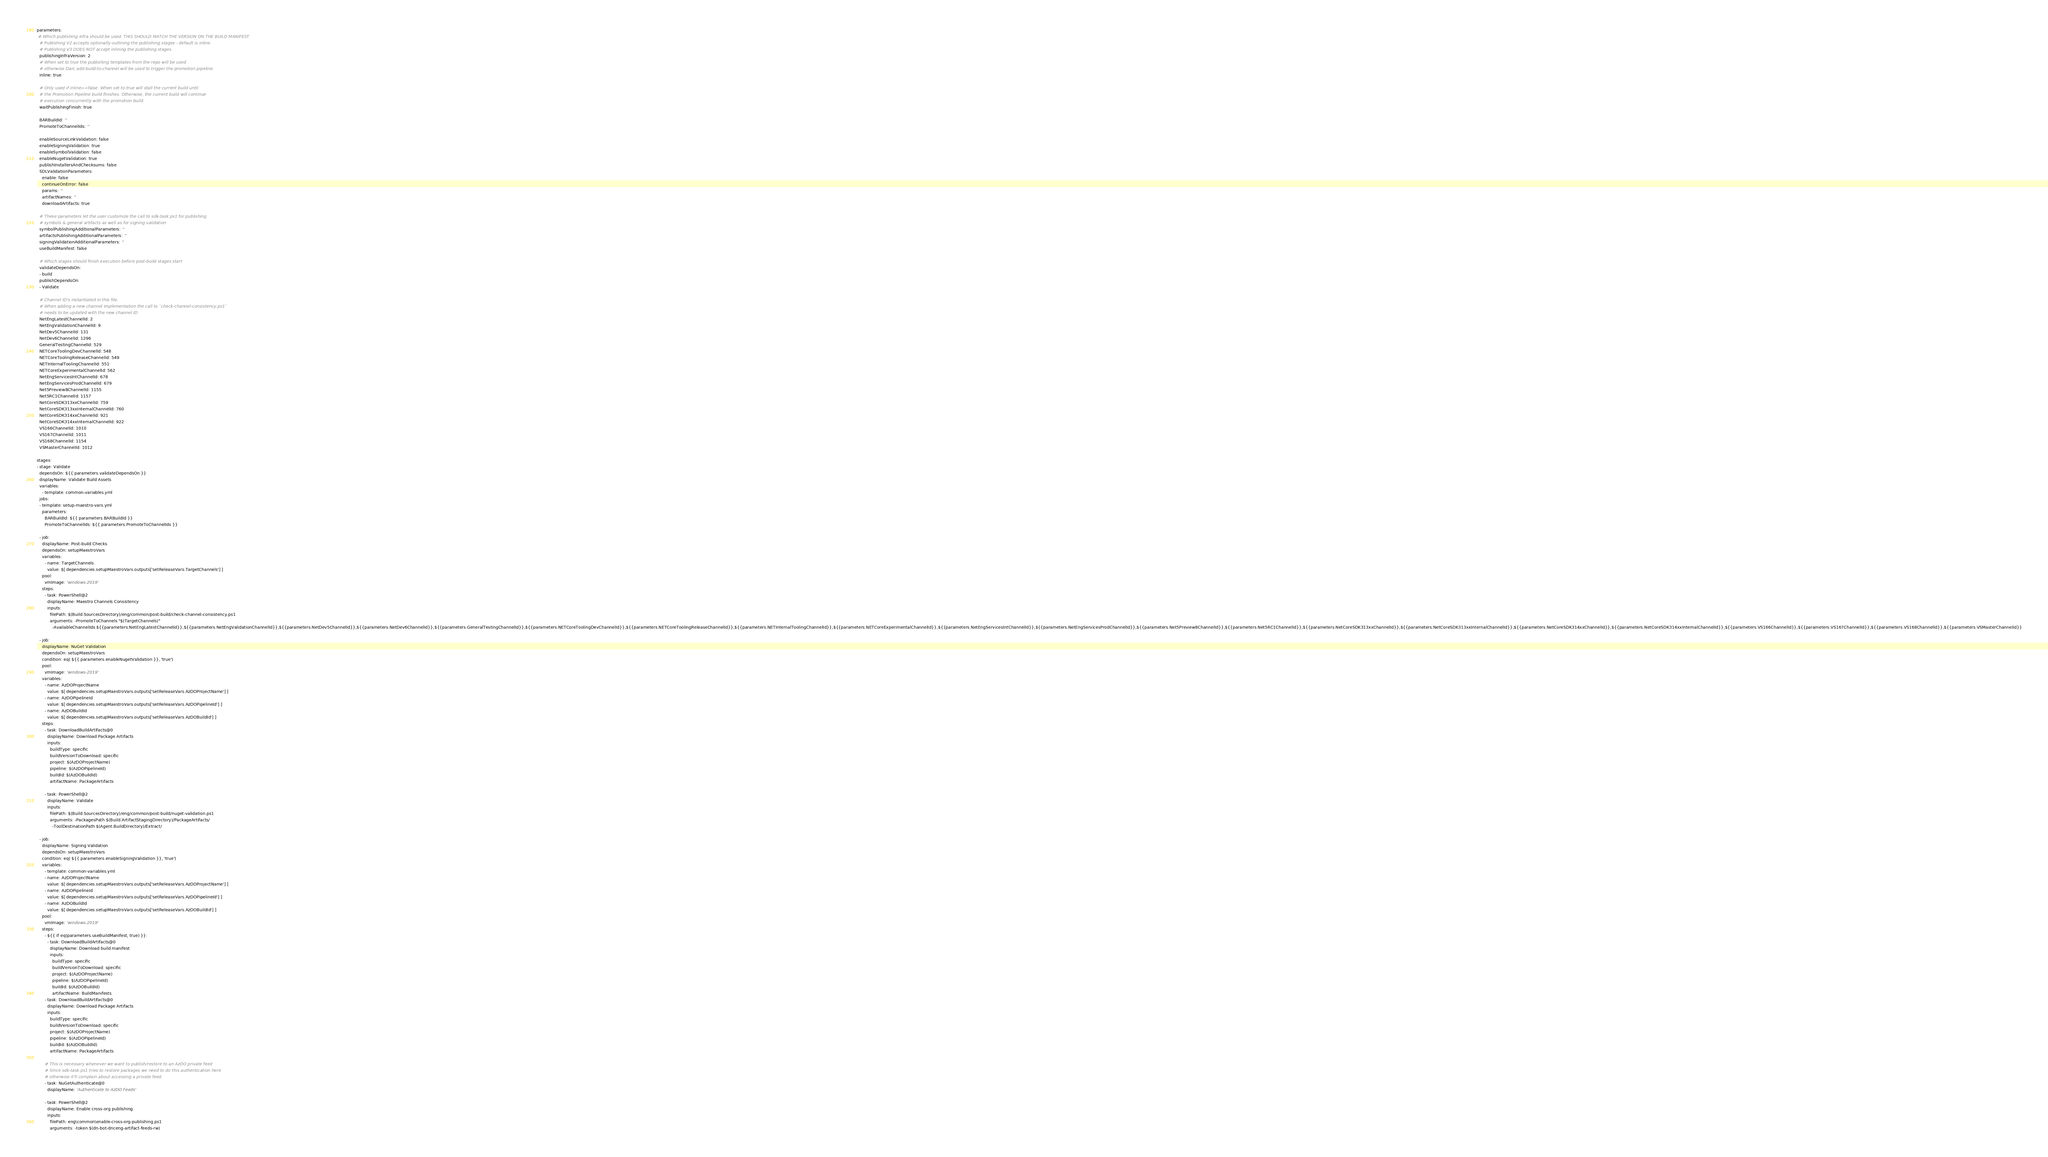Convert code to text. <code><loc_0><loc_0><loc_500><loc_500><_YAML_>parameters:
 # Which publishing infra should be used. THIS SHOULD MATCH THE VERSION ON THE BUILD MANIFEST.
  # Publishing V2 accepts optionally outlining the publishing stages - default is inline.
  # Publishing V3 DOES NOT accept inlining the publishing stages.
  publishingInfraVersion: 2
  # When set to true the publishing templates from the repo will be used
  # otherwise Darc add-build-to-channel will be used to trigger the promotion pipeline
  inline: true

  # Only used if inline==false. When set to true will stall the current build until
  # the Promotion Pipeline build finishes. Otherwise, the current build will continue 
  # execution concurrently with the promotion build.
  waitPublishingFinish: true

  BARBuildId: ''
  PromoteToChannelIds: ''

  enableSourceLinkValidation: false
  enableSigningValidation: true
  enableSymbolValidation: false
  enableNugetValidation: true
  publishInstallersAndChecksums: false
  SDLValidationParameters:
    enable: false
    continueOnError: false
    params: ''
    artifactNames: ''
    downloadArtifacts: true

  # These parameters let the user customize the call to sdk-task.ps1 for publishing
  # symbols & general artifacts as well as for signing validation
  symbolPublishingAdditionalParameters: ''
  artifactsPublishingAdditionalParameters: ''
  signingValidationAdditionalParameters: ''
  useBuildManifest: false

  # Which stages should finish execution before post-build stages start
  validateDependsOn:
  - build
  publishDependsOn: 
  - Validate

  # Channel ID's instantiated in this file.
  # When adding a new channel implementation the call to `check-channel-consistency.ps1` 
  # needs to be updated with the new channel ID
  NetEngLatestChannelId: 2
  NetEngValidationChannelId: 9
  NetDev5ChannelId: 131
  NetDev6ChannelId: 1296
  GeneralTestingChannelId: 529
  NETCoreToolingDevChannelId: 548
  NETCoreToolingReleaseChannelId: 549
  NETInternalToolingChannelId: 551
  NETCoreExperimentalChannelId: 562
  NetEngServicesIntChannelId: 678
  NetEngServicesProdChannelId: 679
  Net5Preview8ChannelId: 1155
  Net5RC1ChannelId: 1157
  NetCoreSDK313xxChannelId: 759
  NetCoreSDK313xxInternalChannelId: 760
  NetCoreSDK314xxChannelId: 921
  NetCoreSDK314xxInternalChannelId: 922
  VS166ChannelId: 1010
  VS167ChannelId: 1011
  VS168ChannelId: 1154
  VSMasterChannelId: 1012
  
stages:
- stage: Validate
  dependsOn: ${{ parameters.validateDependsOn }}
  displayName: Validate Build Assets
  variables:
    - template: common-variables.yml
  jobs:
  - template: setup-maestro-vars.yml
    parameters:
      BARBuildId: ${{ parameters.BARBuildId }}
      PromoteToChannelIds: ${{ parameters.PromoteToChannelIds }}

  - job:
    displayName: Post-build Checks
    dependsOn: setupMaestroVars
    variables:
      - name: TargetChannels
        value: $[ dependencies.setupMaestroVars.outputs['setReleaseVars.TargetChannels'] ]
    pool:
      vmImage: 'windows-2019'
    steps:
      - task: PowerShell@2
        displayName: Maestro Channels Consistency
        inputs:
          filePath: $(Build.SourcesDirectory)/eng/common/post-build/check-channel-consistency.ps1
          arguments: -PromoteToChannels "$(TargetChannels)"
            -AvailableChannelIds ${{parameters.NetEngLatestChannelId}},${{parameters.NetEngValidationChannelId}},${{parameters.NetDev5ChannelId}},${{parameters.NetDev6ChannelId}},${{parameters.GeneralTestingChannelId}},${{parameters.NETCoreToolingDevChannelId}},${{parameters.NETCoreToolingReleaseChannelId}},${{parameters.NETInternalToolingChannelId}},${{parameters.NETCoreExperimentalChannelId}},${{parameters.NetEngServicesIntChannelId}},${{parameters.NetEngServicesProdChannelId}},${{parameters.Net5Preview8ChannelId}},${{parameters.Net5RC1ChannelId}},${{parameters.NetCoreSDK313xxChannelId}},${{parameters.NetCoreSDK313xxInternalChannelId}},${{parameters.NetCoreSDK314xxChannelId}},${{parameters.NetCoreSDK314xxInternalChannelId}},${{parameters.VS166ChannelId}},${{parameters.VS167ChannelId}},${{parameters.VS168ChannelId}},${{parameters.VSMasterChannelId}}

  - job:
    displayName: NuGet Validation
    dependsOn: setupMaestroVars
    condition: eq( ${{ parameters.enableNugetValidation }}, 'true')
    pool:
      vmImage: 'windows-2019'
    variables:
      - name: AzDOProjectName
        value: $[ dependencies.setupMaestroVars.outputs['setReleaseVars.AzDOProjectName'] ]
      - name: AzDOPipelineId
        value: $[ dependencies.setupMaestroVars.outputs['setReleaseVars.AzDOPipelineId'] ]
      - name: AzDOBuildId
        value: $[ dependencies.setupMaestroVars.outputs['setReleaseVars.AzDOBuildId'] ]
    steps:
      - task: DownloadBuildArtifacts@0
        displayName: Download Package Artifacts
        inputs:
          buildType: specific
          buildVersionToDownload: specific
          project: $(AzDOProjectName)
          pipeline: $(AzDOPipelineId)
          buildId: $(AzDOBuildId)
          artifactName: PackageArtifacts

      - task: PowerShell@2
        displayName: Validate
        inputs:
          filePath: $(Build.SourcesDirectory)/eng/common/post-build/nuget-validation.ps1
          arguments: -PackagesPath $(Build.ArtifactStagingDirectory)/PackageArtifacts/ 
            -ToolDestinationPath $(Agent.BuildDirectory)/Extract/ 

  - job:
    displayName: Signing Validation
    dependsOn: setupMaestroVars
    condition: eq( ${{ parameters.enableSigningValidation }}, 'true')
    variables:
      - template: common-variables.yml
      - name: AzDOProjectName
        value: $[ dependencies.setupMaestroVars.outputs['setReleaseVars.AzDOProjectName'] ]
      - name: AzDOPipelineId
        value: $[ dependencies.setupMaestroVars.outputs['setReleaseVars.AzDOPipelineId'] ]
      - name: AzDOBuildId
        value: $[ dependencies.setupMaestroVars.outputs['setReleaseVars.AzDOBuildId'] ]
    pool:
      vmImage: 'windows-2019'
    steps:
      - ${{ if eq(parameters.useBuildManifest, true) }}:
        - task: DownloadBuildArtifacts@0
          displayName: Download build manifest
          inputs:
            buildType: specific
            buildVersionToDownload: specific
            project: $(AzDOProjectName)
            pipeline: $(AzDOPipelineId)
            buildId: $(AzDOBuildId)
            artifactName: BuildManifests
      - task: DownloadBuildArtifacts@0
        displayName: Download Package Artifacts
        inputs:
          buildType: specific
          buildVersionToDownload: specific
          project: $(AzDOProjectName)
          pipeline: $(AzDOPipelineId)
          buildId: $(AzDOBuildId)
          artifactName: PackageArtifacts

      # This is necessary whenever we want to publish/restore to an AzDO private feed
      # Since sdk-task.ps1 tries to restore packages we need to do this authentication here
      # otherwise it'll complain about accessing a private feed.
      - task: NuGetAuthenticate@0
        displayName: 'Authenticate to AzDO Feeds'

      - task: PowerShell@2
        displayName: Enable cross-org publishing
        inputs:
          filePath: eng\common\enable-cross-org-publishing.ps1
          arguments: -token $(dn-bot-dnceng-artifact-feeds-rw)
</code> 